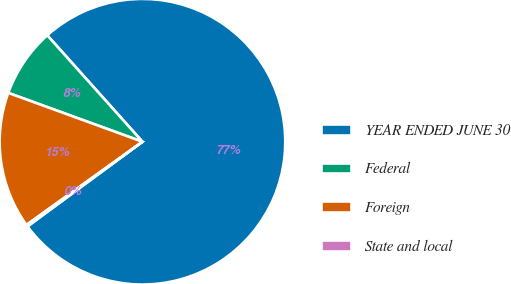Convert chart. <chart><loc_0><loc_0><loc_500><loc_500><pie_chart><fcel>YEAR ENDED JUNE 30<fcel>Federal<fcel>Foreign<fcel>State and local<nl><fcel>76.51%<fcel>7.83%<fcel>15.46%<fcel>0.2%<nl></chart> 